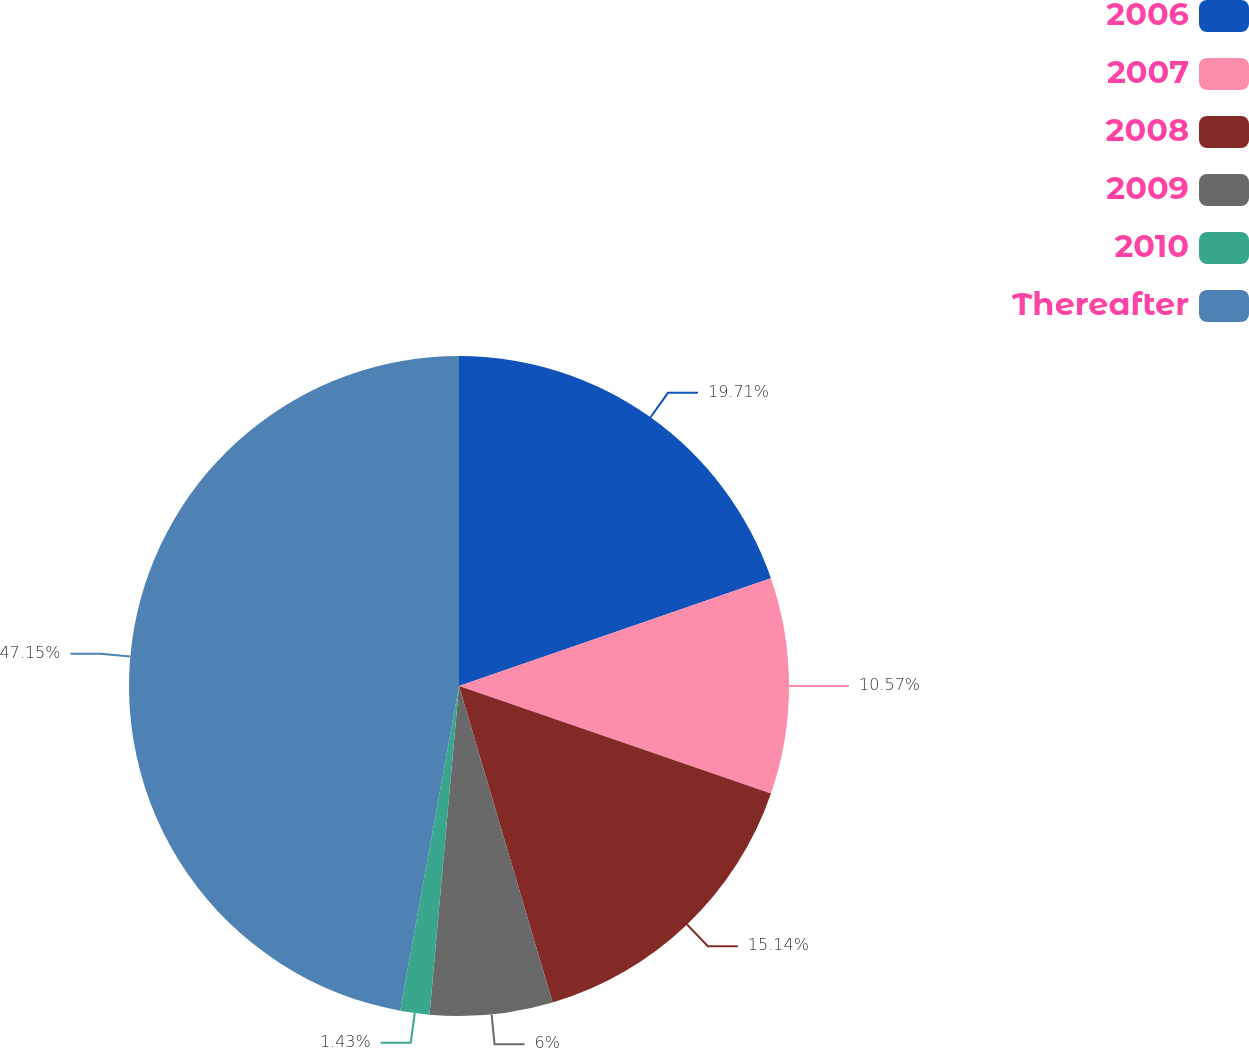Convert chart. <chart><loc_0><loc_0><loc_500><loc_500><pie_chart><fcel>2006<fcel>2007<fcel>2008<fcel>2009<fcel>2010<fcel>Thereafter<nl><fcel>19.71%<fcel>10.57%<fcel>15.14%<fcel>6.0%<fcel>1.43%<fcel>47.14%<nl></chart> 